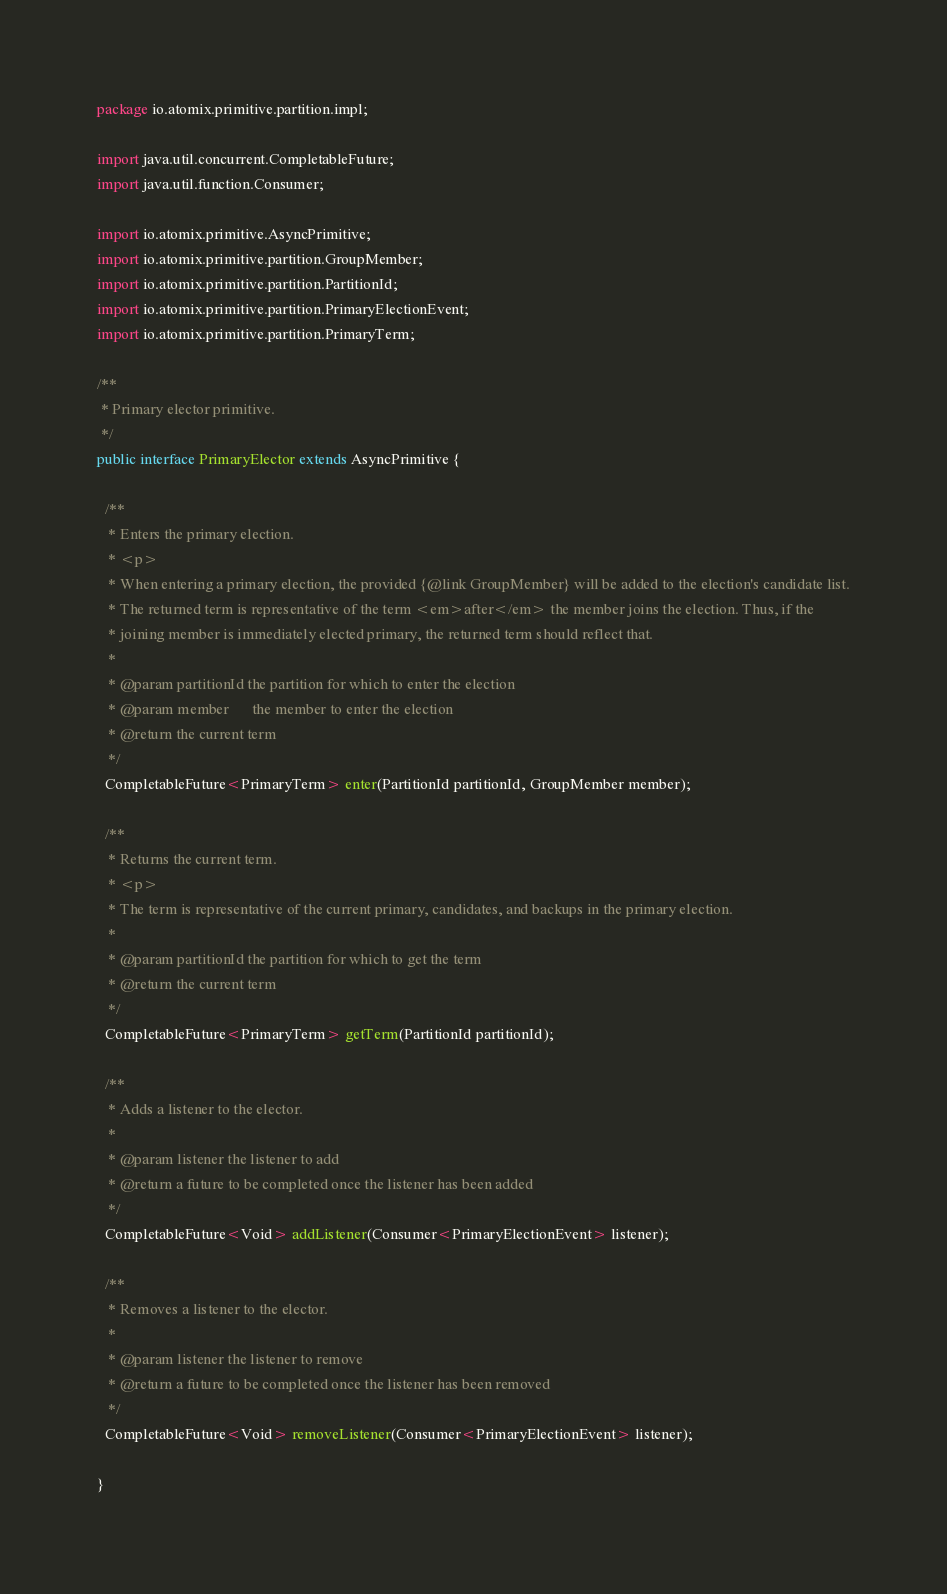<code> <loc_0><loc_0><loc_500><loc_500><_Java_>package io.atomix.primitive.partition.impl;

import java.util.concurrent.CompletableFuture;
import java.util.function.Consumer;

import io.atomix.primitive.AsyncPrimitive;
import io.atomix.primitive.partition.GroupMember;
import io.atomix.primitive.partition.PartitionId;
import io.atomix.primitive.partition.PrimaryElectionEvent;
import io.atomix.primitive.partition.PrimaryTerm;

/**
 * Primary elector primitive.
 */
public interface PrimaryElector extends AsyncPrimitive {

  /**
   * Enters the primary election.
   * <p>
   * When entering a primary election, the provided {@link GroupMember} will be added to the election's candidate list.
   * The returned term is representative of the term <em>after</em> the member joins the election. Thus, if the
   * joining member is immediately elected primary, the returned term should reflect that.
   *
   * @param partitionId the partition for which to enter the election
   * @param member      the member to enter the election
   * @return the current term
   */
  CompletableFuture<PrimaryTerm> enter(PartitionId partitionId, GroupMember member);

  /**
   * Returns the current term.
   * <p>
   * The term is representative of the current primary, candidates, and backups in the primary election.
   *
   * @param partitionId the partition for which to get the term
   * @return the current term
   */
  CompletableFuture<PrimaryTerm> getTerm(PartitionId partitionId);

  /**
   * Adds a listener to the elector.
   *
   * @param listener the listener to add
   * @return a future to be completed once the listener has been added
   */
  CompletableFuture<Void> addListener(Consumer<PrimaryElectionEvent> listener);

  /**
   * Removes a listener to the elector.
   *
   * @param listener the listener to remove
   * @return a future to be completed once the listener has been removed
   */
  CompletableFuture<Void> removeListener(Consumer<PrimaryElectionEvent> listener);

}
</code> 